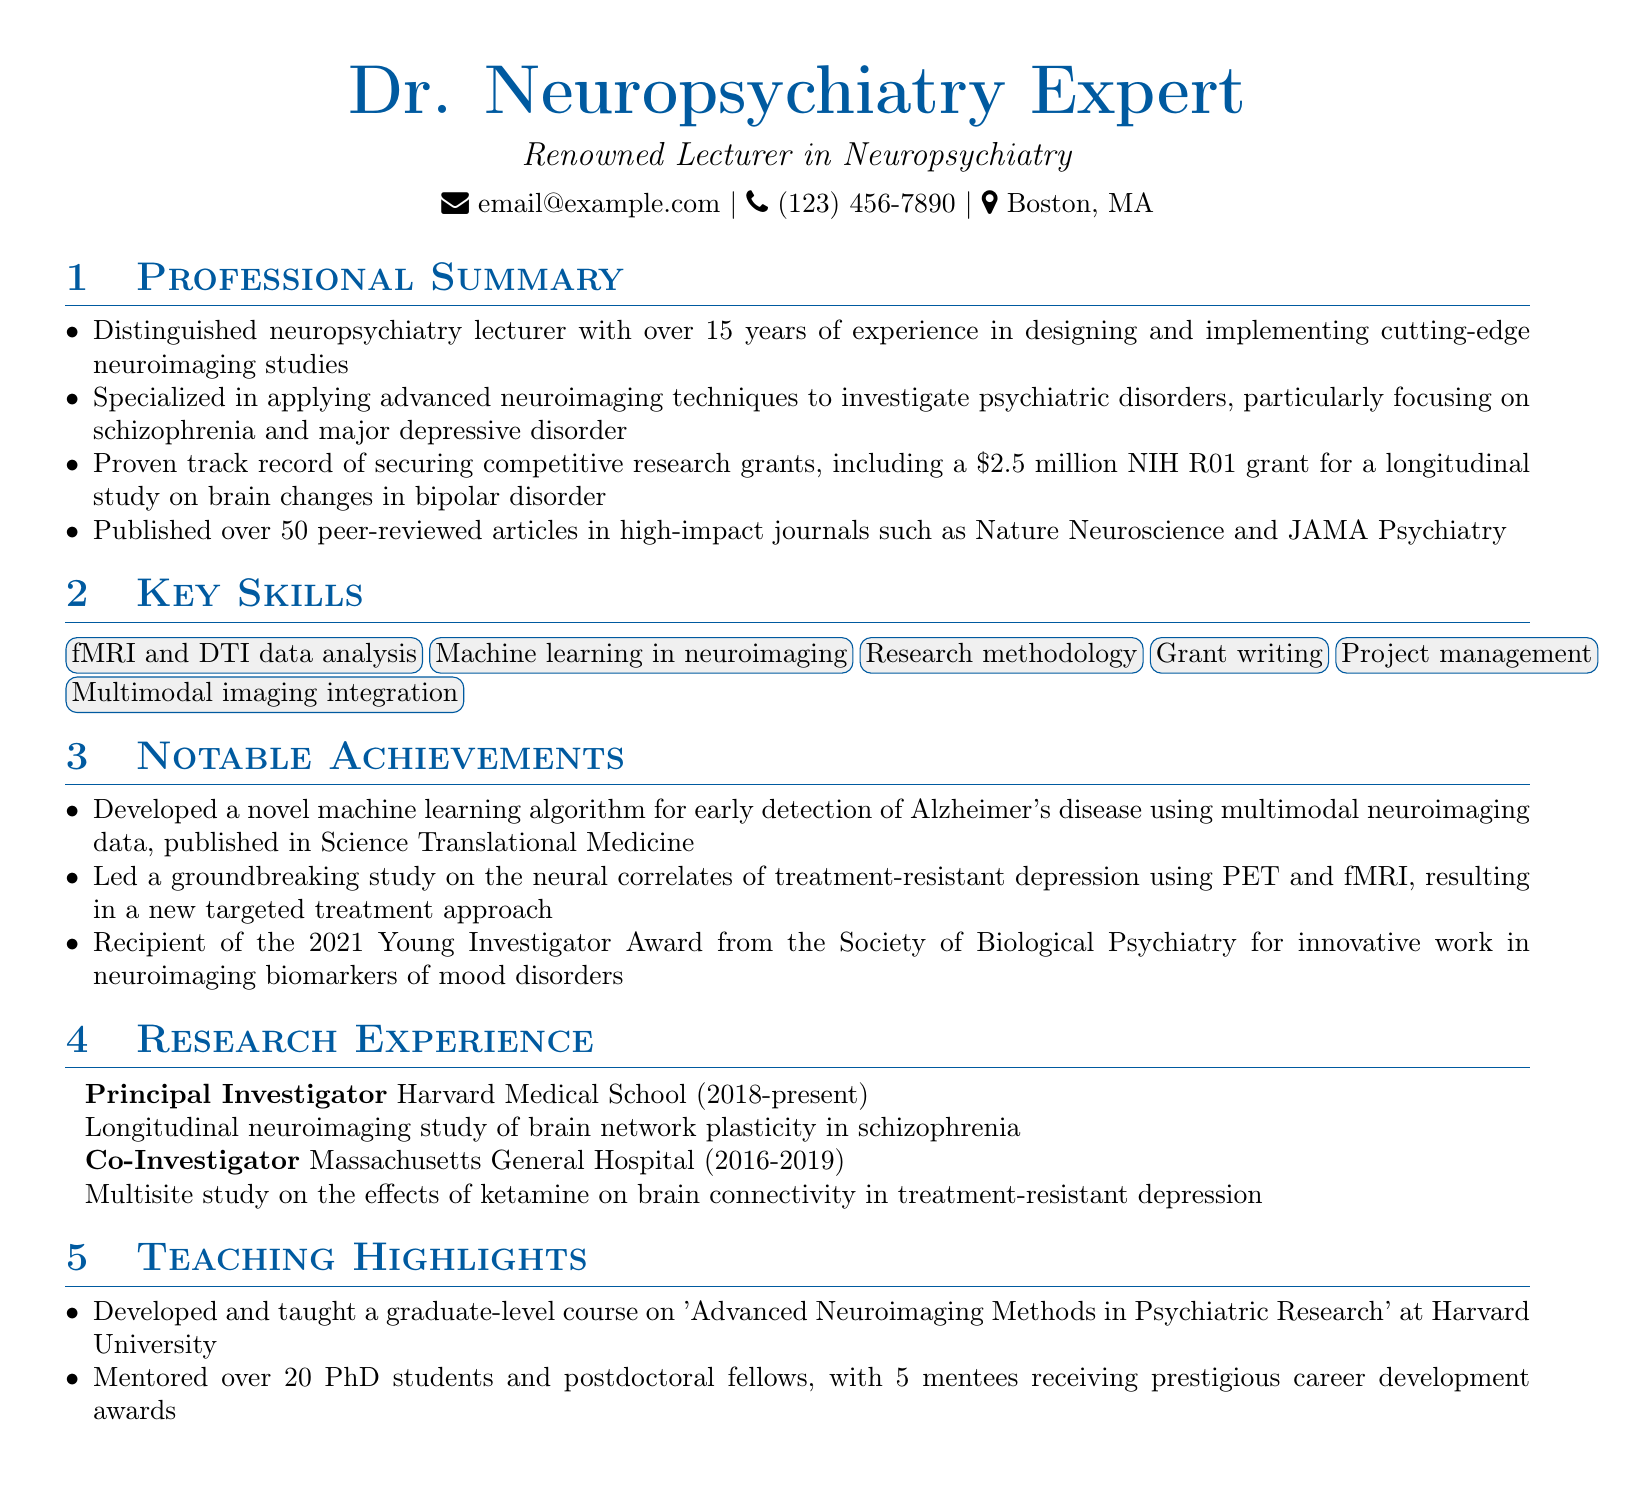What is the primary institution where the lecturer works? The lecturer is primarily associated with Harvard Medical School, where they hold the position of Principal Investigator.
Answer: Harvard Medical School How many peer-reviewed articles has the lecturer published? The document states that the lecturer has published over 50 peer-reviewed articles in high-impact journals.
Answer: Over 50 What is the focus of the longitudinal neuroimaging study led by the lecturer? The longitudinal study focuses on brain network plasticity specifically in schizophrenia.
Answer: Brain network plasticity in schizophrenia What notable award did the lecturer receive in 2021? The lecturer received the Young Investigator Award from the Society of Biological Psychiatry for their innovative work.
Answer: Young Investigator Award How many PhD students and postdoctoral fellows has the lecturer mentored? The lecturer has mentored over 20 PhD students and postdoctoral fellows.
Answer: Over 20 What advanced imaging technique does the lecturer apply to psychiatric disorders? The lecturer specializes in applying advanced neuroimaging techniques, particularly fMRI and DTI data analysis.
Answer: fMRI and DTI data analysis What significant grant did the lecturer secure and for what amount? The lecturer secured a $2.5 million NIH R01 grant for a longitudinal study on brain changes in bipolar disorder.
Answer: $2.5 million What course did the lecturer develop at Harvard University? The lecturer developed and taught a course titled 'Advanced Neuroimaging Methods in Psychiatric Research'.
Answer: Advanced Neuroimaging Methods in Psychiatric Research 